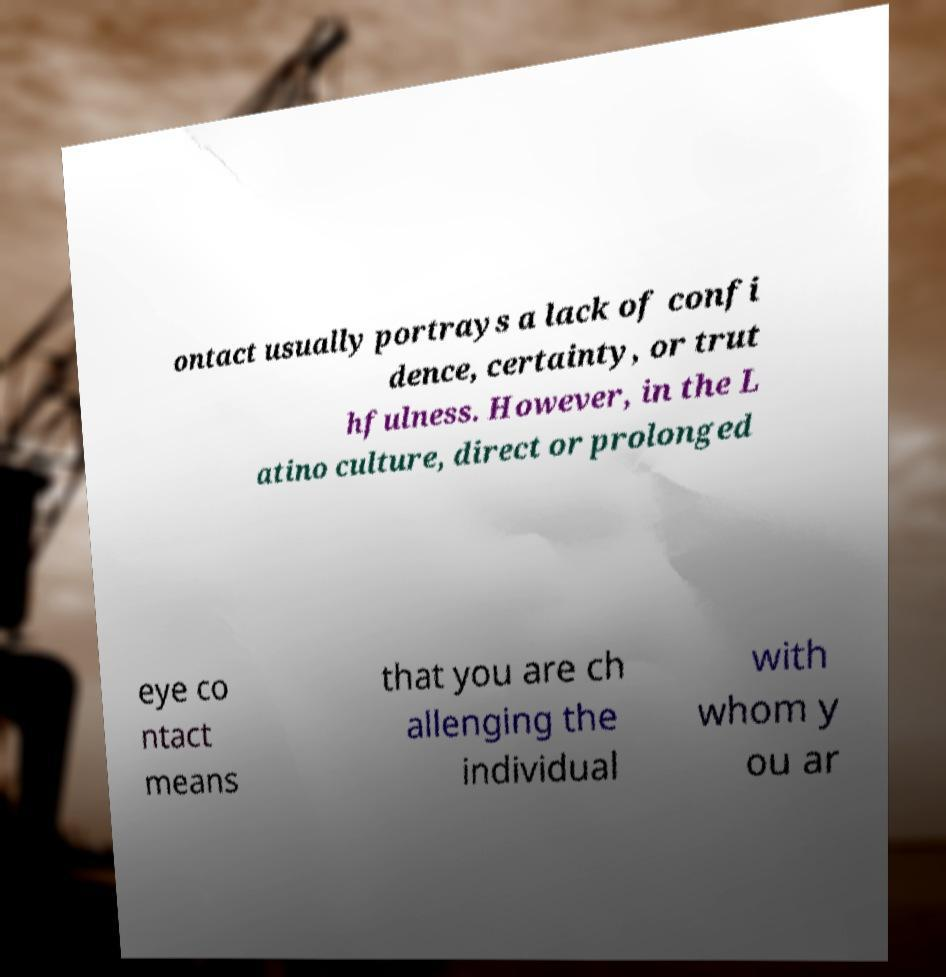Could you extract and type out the text from this image? ontact usually portrays a lack of confi dence, certainty, or trut hfulness. However, in the L atino culture, direct or prolonged eye co ntact means that you are ch allenging the individual with whom y ou ar 